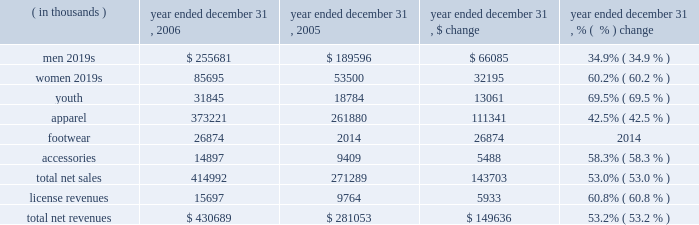Year ended december 31 , 2006 compared to year ended december 31 , 2005 net revenues increased $ 149.6 million , or 53.2% ( 53.2 % ) , to $ 430.7 million in 2006 from $ 281.1 million in 2005 .
This increase was the result of increases in both our net sales and license revenues as noted in the product category table below. .
Net sales increased $ 143.7 million , or 53.0% ( 53.0 % ) , to $ 415.0 million for the year ended december 31 , 2006 from $ 271.3 million during the same period in 2005 as noted in the table above .
The increase in net sales primarily reflects : 2022 $ 26.9 million of footwear product sales , primarily football cleats introduced in the second quarter of 2006 , and baseball cleats introduced in the fourth quarter of 2006 ; 2022 continued unit volume growth of our existing products , such as coldgear ae compression products , primarily sold to existing retail customers due to additional retail stores and expanded floor space ; 2022 growth in the average selling price of apparel products within all categories ; 2022 increased women 2019s and youth market penetration by leveraging current customer relationships ; and 2022 product introductions subsequent to december 31 , 2005 within all product categories , most significantly in our compression and training products .
License revenues increased $ 5.9 million , or 60.8% ( 60.8 % ) , to $ 15.7 million for the year ended december 31 , 2006 from $ 9.8 million during the same period in 2005 .
This increase in license revenues was a result of increased sales by our licensees due to increased distribution , continued unit volume growth , new product offerings and new licensing agreements , which included distribution of products to college bookstores and golf pro shops .
Gross profit increased $ 79.7 million to $ 215.6 million in 2006 from $ 135.9 million in 2005 .
Gross profit as a percentage of net revenues , or gross margin , increased approximately 180 basis points to 50.1% ( 50.1 % ) in 2006 from 48.3% ( 48.3 % ) in 2005 .
This increase in gross margin was primarily driven by the following : 2022 lower product costs as a result of variations in product mix and greater supplier discounts for increased volume and lower cost sourcing arrangements , accounting for an approximate 170 basis point increase ; 2022 decreased close-out sales in the 2006 period compared to the 2005 period , accounting for an approximate 70 basis point increase ; 2022 lower customer incentives as a percentage of net revenues , primarily driven by changes to certain customer agreements which decreased discounts while increasing certain customer marketing expenditures recorded in selling , general and administrative expenses , accounting for an approximate 70 basis point increase; .
What was the percentage change in the gross profit from 2005 to 2006? 
Computations: (79.7 / 135.9)
Answer: 0.58646. 